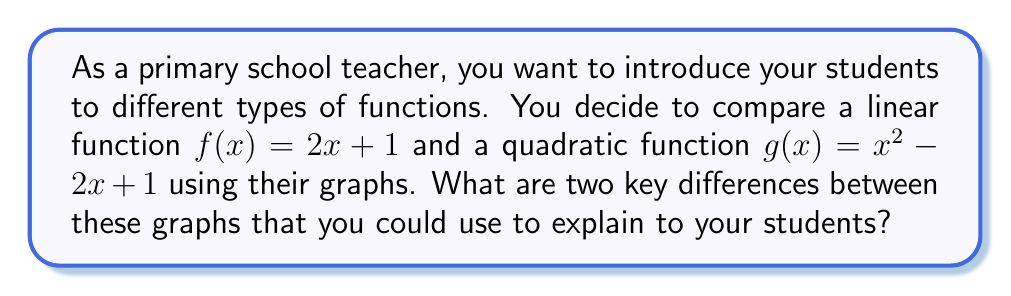Show me your answer to this math problem. Let's approach this step-by-step:

1) First, let's visualize the graphs:

[asy]
import graph;
size(200,200);
real f(real x) {return 2x + 1;}
real g(real x) {return x^2 - 2x + 1;}
draw(graph(f,-3,3),blue);
draw(graph(g,-1,3),red);
xaxis("x");
yaxis("y");
label("f(x)",(-2,f(-2)),NW,blue);
label("g(x)",(2.5,g(2.5)),NE,red);
[/asy]

2) Shape:
   - The linear function $f(x) = 2x + 1$ appears as a straight line.
   - The quadratic function $g(x) = x^2 - 2x + 1$ appears as a curved line, specifically a parabola.

3) Rate of change:
   - For the linear function, the rate of change is constant. The slope is 2, meaning for every 1 unit increase in x, y increases by 2.
   - For the quadratic function, the rate of change is not constant. The slope changes as x changes, giving the curved shape.

4) y-intercept:
   - Both functions have the same y-intercept at (0,1), as both equations equal 1 when x = 0.

5) x-intercepts:
   - The linear function has one x-intercept at (-0.5, 0).
   - The quadratic function has two x-intercepts at approximately (0.41, 0) and (1.59, 0).

6) Symmetry:
   - The linear function does not have symmetry.
   - The quadratic function has symmetry around its vertex, which is at (1, 0).

The two key differences that would be most appropriate for primary school students are:
1) The shape: straight line vs. curved line (parabola)
2) The rate of change: constant vs. varying
Answer: Shape (straight vs. curved) and rate of change (constant vs. varying) 